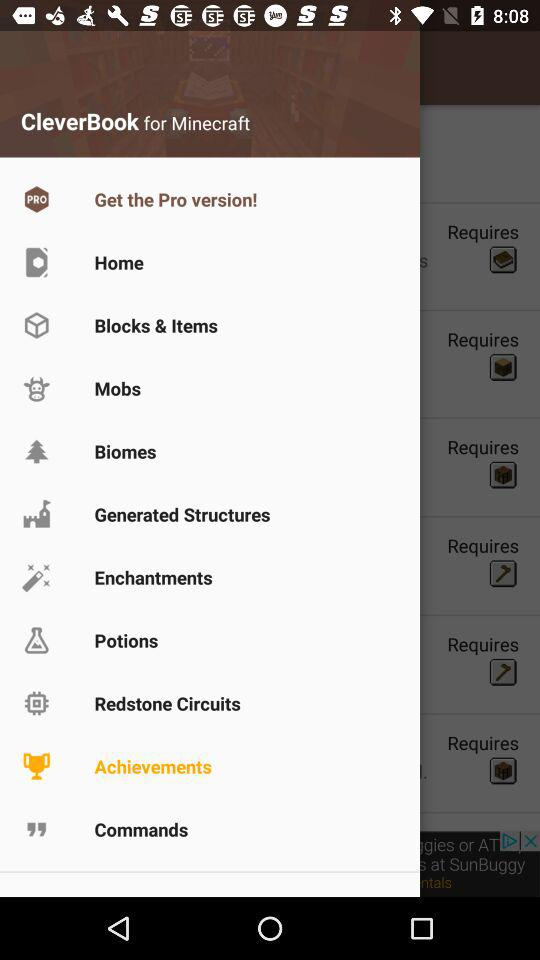What is the name of the application? The name of the application "CleverBook for Minecraft". 